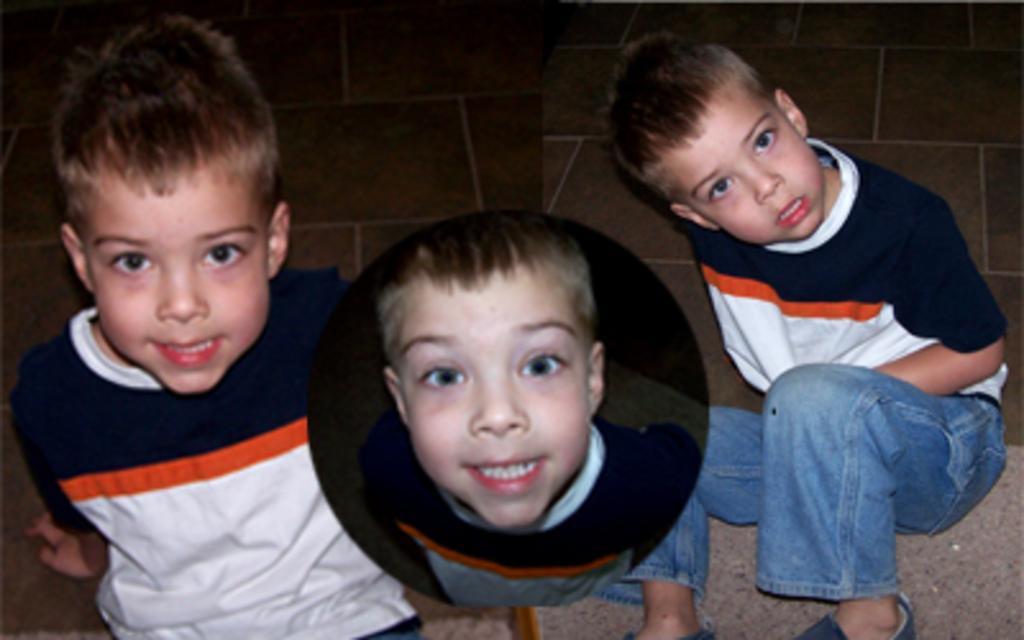In one or two sentences, can you explain what this image depicts? This picture describe about the three collage photograph of the small boy wearing white and blue t- shirt sitting on the ground smiling and giving a pose into the camera. 